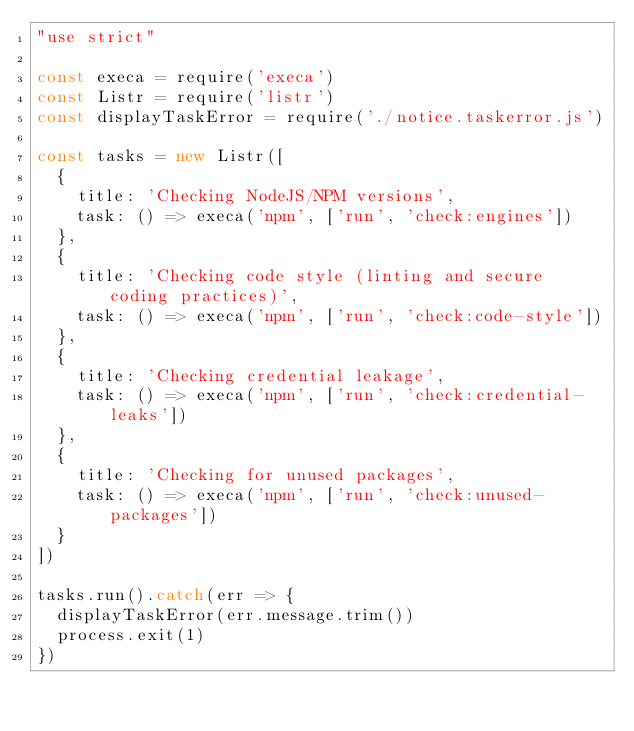Convert code to text. <code><loc_0><loc_0><loc_500><loc_500><_JavaScript_>"use strict"

const execa = require('execa')
const Listr = require('listr')
const displayTaskError = require('./notice.taskerror.js')
 
const tasks = new Listr([
  {
    title: 'Checking NodeJS/NPM versions',
    task: () => execa('npm', ['run', 'check:engines'])
  },
  {
    title: 'Checking code style (linting and secure coding practices)',
    task: () => execa('npm', ['run', 'check:code-style'])
  },
  {
    title: 'Checking credential leakage',
    task: () => execa('npm', ['run', 'check:credential-leaks'])
  },
  {
    title: 'Checking for unused packages',
    task: () => execa('npm', ['run', 'check:unused-packages'])
  }
])
 
tasks.run().catch(err => {
  displayTaskError(err.message.trim())
  process.exit(1)
})
</code> 